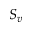Convert formula to latex. <formula><loc_0><loc_0><loc_500><loc_500>S _ { v }</formula> 